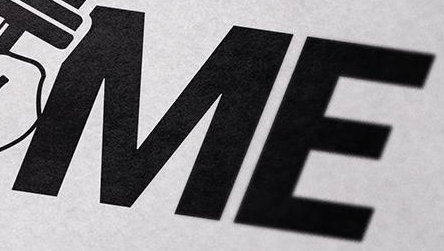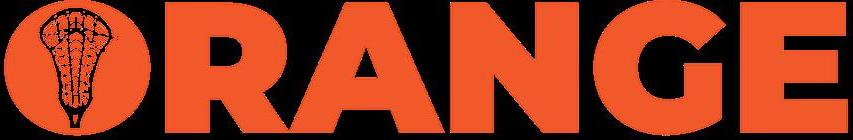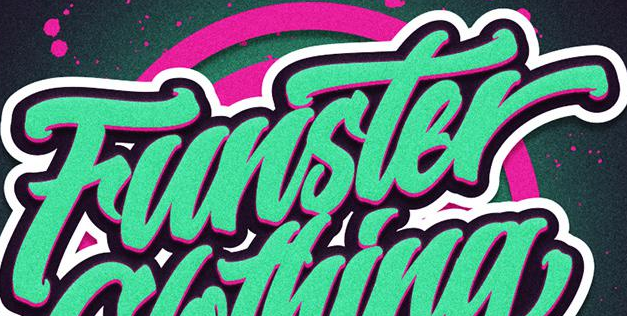What words can you see in these images in sequence, separated by a semicolon? ME; ORANGE; Funster 